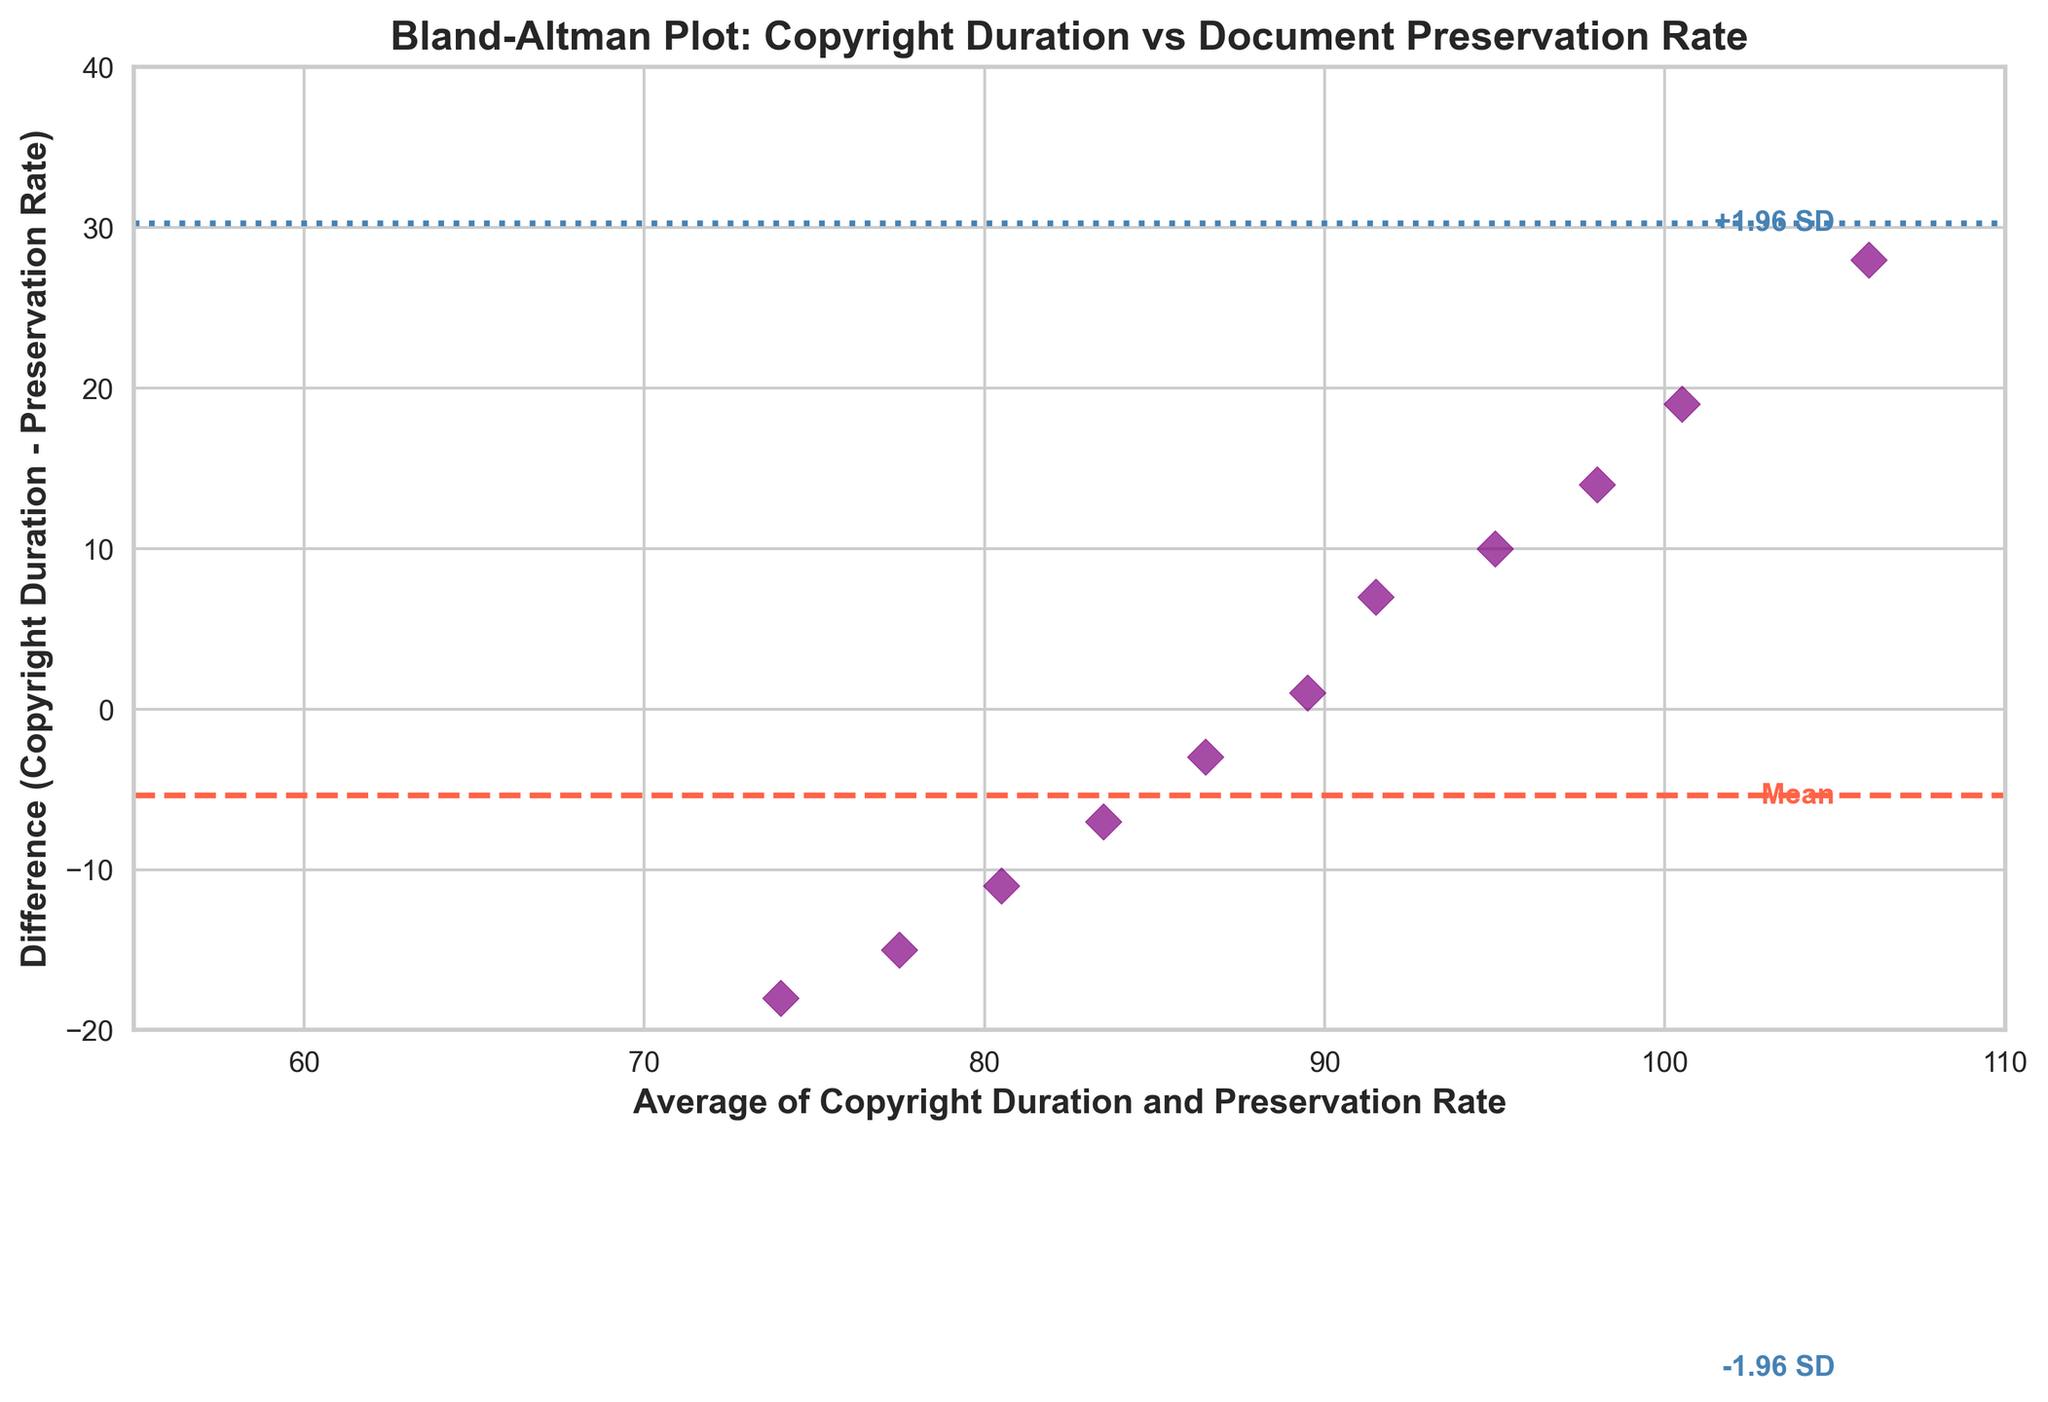What is the title of the plot? The title of a plot is usually displayed at the top of the figure. In this case, we can see that the title is "Bland-Altman Plot: Copyright Duration vs Document Preservation Rate".
Answer: Bland-Altman Plot: Copyright Duration vs Document Preservation Rate How many data points are shown in the plot? The plot shows individual data points as purple diamonds. By counting them, we can see there are 15 data points.
Answer: 15 What does the x-axis represent? The x-axis label explains what it represents. In this plot, the label is "Average of Copyright Duration and Preservation Rate", indicating that the x-axis shows the average of these two values.
Answer: Average of Copyright Duration and Preservation Rate What is the mean difference line colored? The color and style of lines can help distinguish them. The mean difference line is colored red and is displayed as a dashed line.
Answer: Red What is the value of the mean difference line? The mean difference line is labeled with the word "Mean". By looking at its position, we can see the mean difference value is around 5.
Answer: 5 What are the upper and lower limits of agreement shown in the plot? The plot includes two limits of agreement lines, labeled as "+1.96 SD" and "-1.96 SD". The upper limit of agreement is around 26.98, and the lower limit of agreement is around -16.98.
Answer: 26.98 and -16.98 What's the range of the x-axis? By observing the limits on the x-axis, we can see that the range is from approximately 55 to 110.
Answer: 55 to 110 What's the difference between the highest data point and the mean difference line? The highest data point appears to be at an approximate y-value of 30. The mean difference line is at 5. Therefore, the difference is 30 - 5 = 25.
Answer: 25 Which data point has the highest average? The plot shows the averages on the x-axis. The highest data point on the x-axis is around 106, making it the data point with the highest average.
Answer: 106 Are any data points within the limits of agreement? The majority of the data points lie between the upper and lower limits of agreement (+1.96 SD and -1.96 SD lines), indicating that most of them fall within the acceptable range.
Answer: Yes Is there any visible trend or pattern in the relationship between the average values and differences? Observing the scatter of points, we see no clear trend or pattern; the differences appear random around the mean difference line regardless of the average value.
Answer: No 